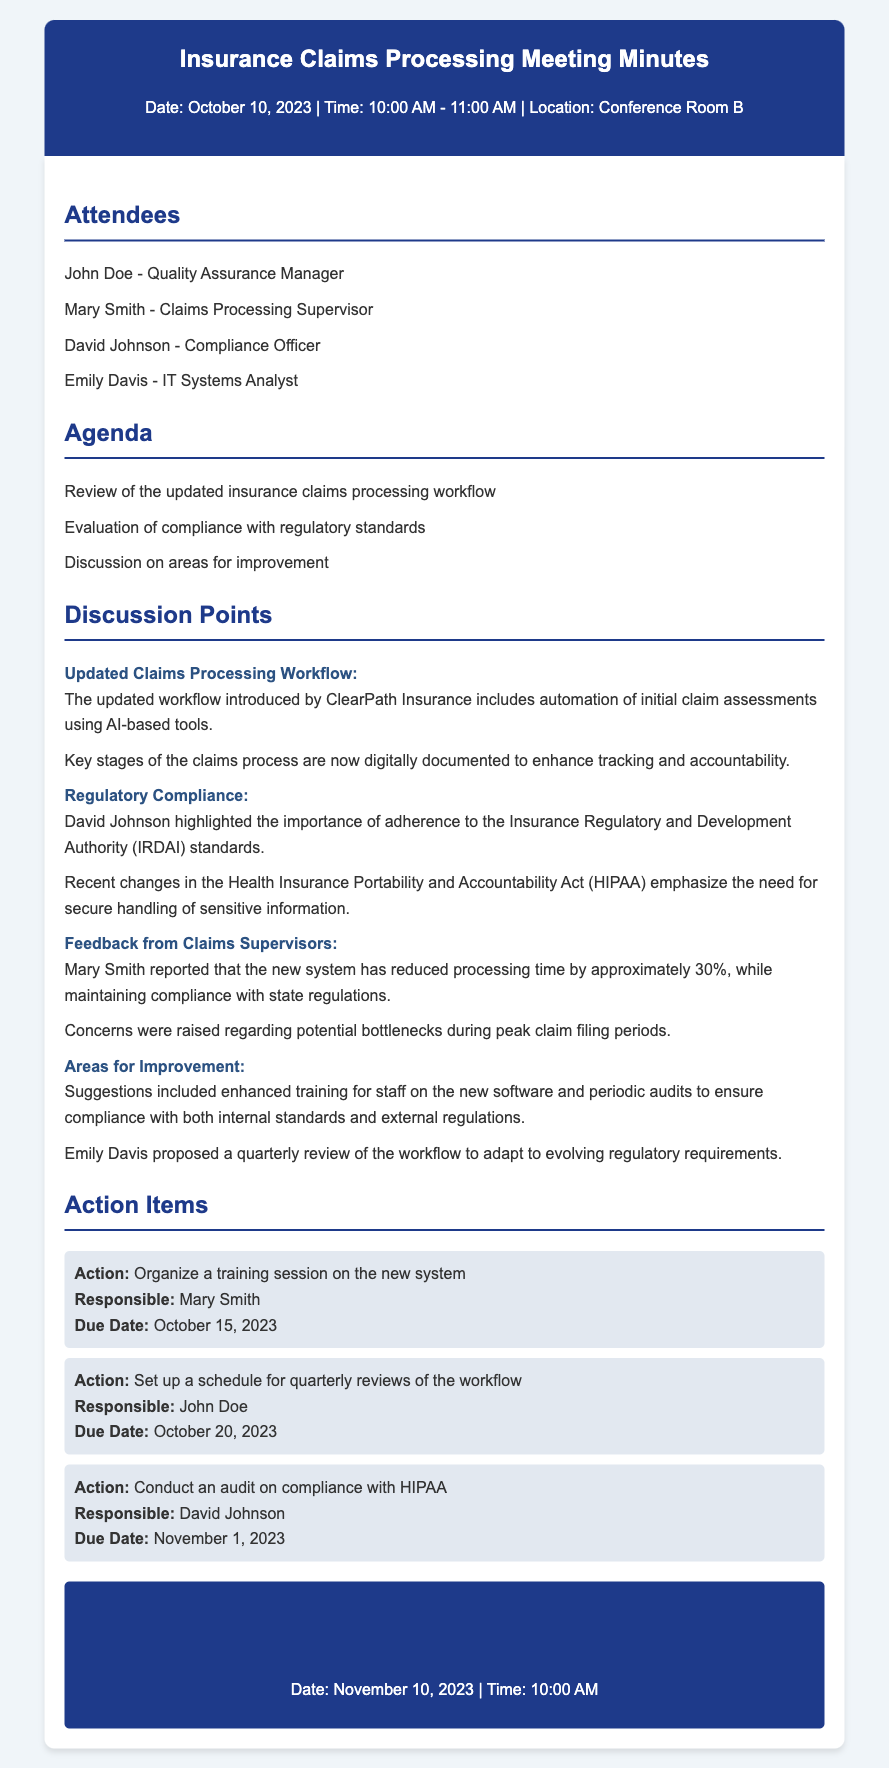what date was the meeting held? The meeting date can be found at the top of the document.
Answer: October 10, 2023 who is responsible for organizing the training session? The responsible person for the training session is listed in the action items section.
Answer: Mary Smith what percentage did the new system reduce processing time? This information is provided in the feedback from claims supervisors section.
Answer: 30% when is the next meeting scheduled? The date of the next meeting is mentioned in the next meeting section.
Answer: November 10, 2023 what is the main tool introduced in the updated claims processing workflow? The main tool is mentioned in the discussion points about the updated claims processing workflow.
Answer: AI-based tools what regulatory standards are mentioned in the document? The document lists specific standards under the compliance discussion points.
Answer: IRDAI and HIPAA how many attendees were present at the meeting? The total number of attendees can be counted in the attendees section.
Answer: Four what is one area suggested for improvement? Areas for improvement are listed under the areas for improvement discussion point.
Answer: Enhanced training for staff 